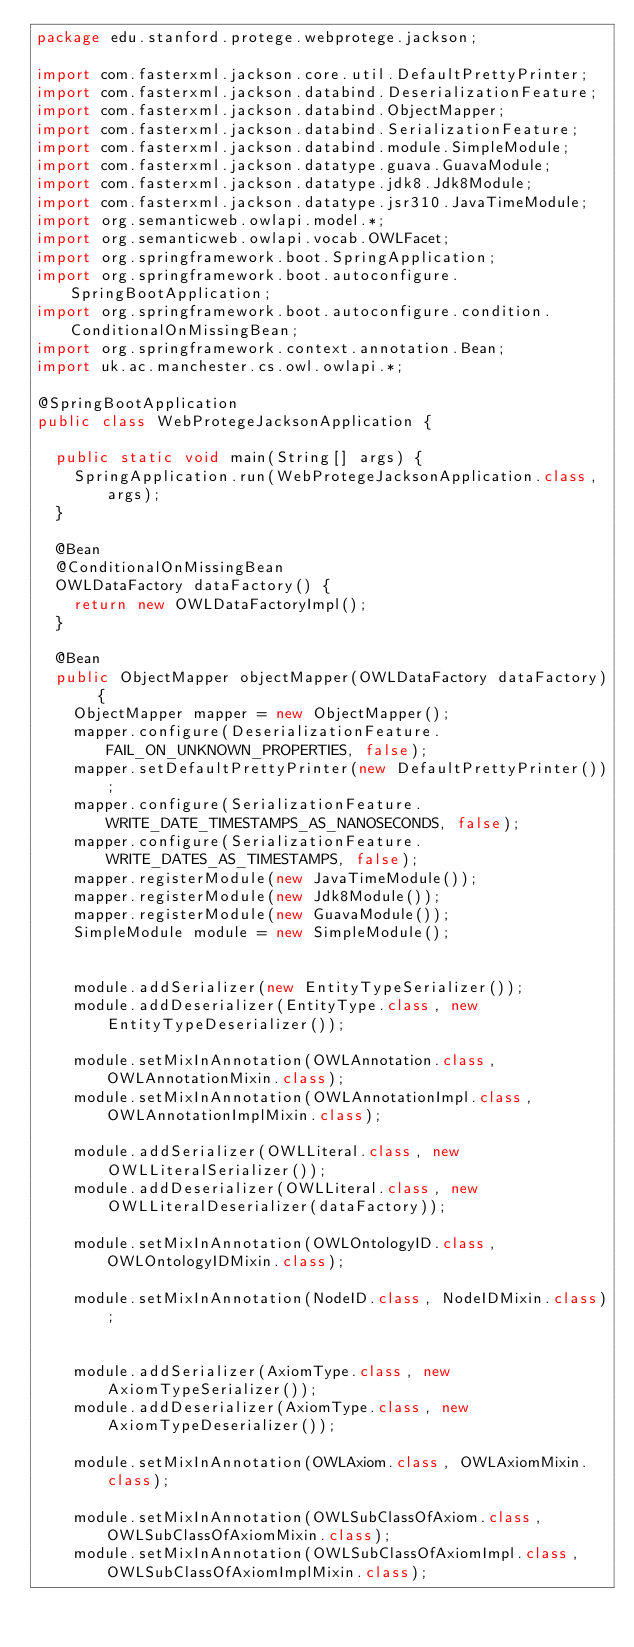<code> <loc_0><loc_0><loc_500><loc_500><_Java_>package edu.stanford.protege.webprotege.jackson;

import com.fasterxml.jackson.core.util.DefaultPrettyPrinter;
import com.fasterxml.jackson.databind.DeserializationFeature;
import com.fasterxml.jackson.databind.ObjectMapper;
import com.fasterxml.jackson.databind.SerializationFeature;
import com.fasterxml.jackson.databind.module.SimpleModule;
import com.fasterxml.jackson.datatype.guava.GuavaModule;
import com.fasterxml.jackson.datatype.jdk8.Jdk8Module;
import com.fasterxml.jackson.datatype.jsr310.JavaTimeModule;
import org.semanticweb.owlapi.model.*;
import org.semanticweb.owlapi.vocab.OWLFacet;
import org.springframework.boot.SpringApplication;
import org.springframework.boot.autoconfigure.SpringBootApplication;
import org.springframework.boot.autoconfigure.condition.ConditionalOnMissingBean;
import org.springframework.context.annotation.Bean;
import uk.ac.manchester.cs.owl.owlapi.*;

@SpringBootApplication
public class WebProtegeJacksonApplication {

	public static void main(String[] args) {
		SpringApplication.run(WebProtegeJacksonApplication.class, args);
	}

	@Bean
	@ConditionalOnMissingBean
	OWLDataFactory dataFactory() {
		return new OWLDataFactoryImpl();
	}

	@Bean
	public ObjectMapper objectMapper(OWLDataFactory dataFactory) {
		ObjectMapper mapper = new ObjectMapper();
		mapper.configure(DeserializationFeature.FAIL_ON_UNKNOWN_PROPERTIES, false);
		mapper.setDefaultPrettyPrinter(new DefaultPrettyPrinter());
		mapper.configure(SerializationFeature.WRITE_DATE_TIMESTAMPS_AS_NANOSECONDS, false);
		mapper.configure(SerializationFeature.WRITE_DATES_AS_TIMESTAMPS, false);
		mapper.registerModule(new JavaTimeModule());
		mapper.registerModule(new Jdk8Module());
		mapper.registerModule(new GuavaModule());
		SimpleModule module = new SimpleModule();


		module.addSerializer(new EntityTypeSerializer());
		module.addDeserializer(EntityType.class, new EntityTypeDeserializer());

		module.setMixInAnnotation(OWLAnnotation.class, OWLAnnotationMixin.class);
		module.setMixInAnnotation(OWLAnnotationImpl.class, OWLAnnotationImplMixin.class);

		module.addSerializer(OWLLiteral.class, new OWLLiteralSerializer());
		module.addDeserializer(OWLLiteral.class, new OWLLiteralDeserializer(dataFactory));

		module.setMixInAnnotation(OWLOntologyID.class, OWLOntologyIDMixin.class);

		module.setMixInAnnotation(NodeID.class, NodeIDMixin.class);


		module.addSerializer(AxiomType.class, new AxiomTypeSerializer());
		module.addDeserializer(AxiomType.class, new AxiomTypeDeserializer());

		module.setMixInAnnotation(OWLAxiom.class, OWLAxiomMixin.class);

		module.setMixInAnnotation(OWLSubClassOfAxiom.class, OWLSubClassOfAxiomMixin.class);
		module.setMixInAnnotation(OWLSubClassOfAxiomImpl.class, OWLSubClassOfAxiomImplMixin.class);
</code> 